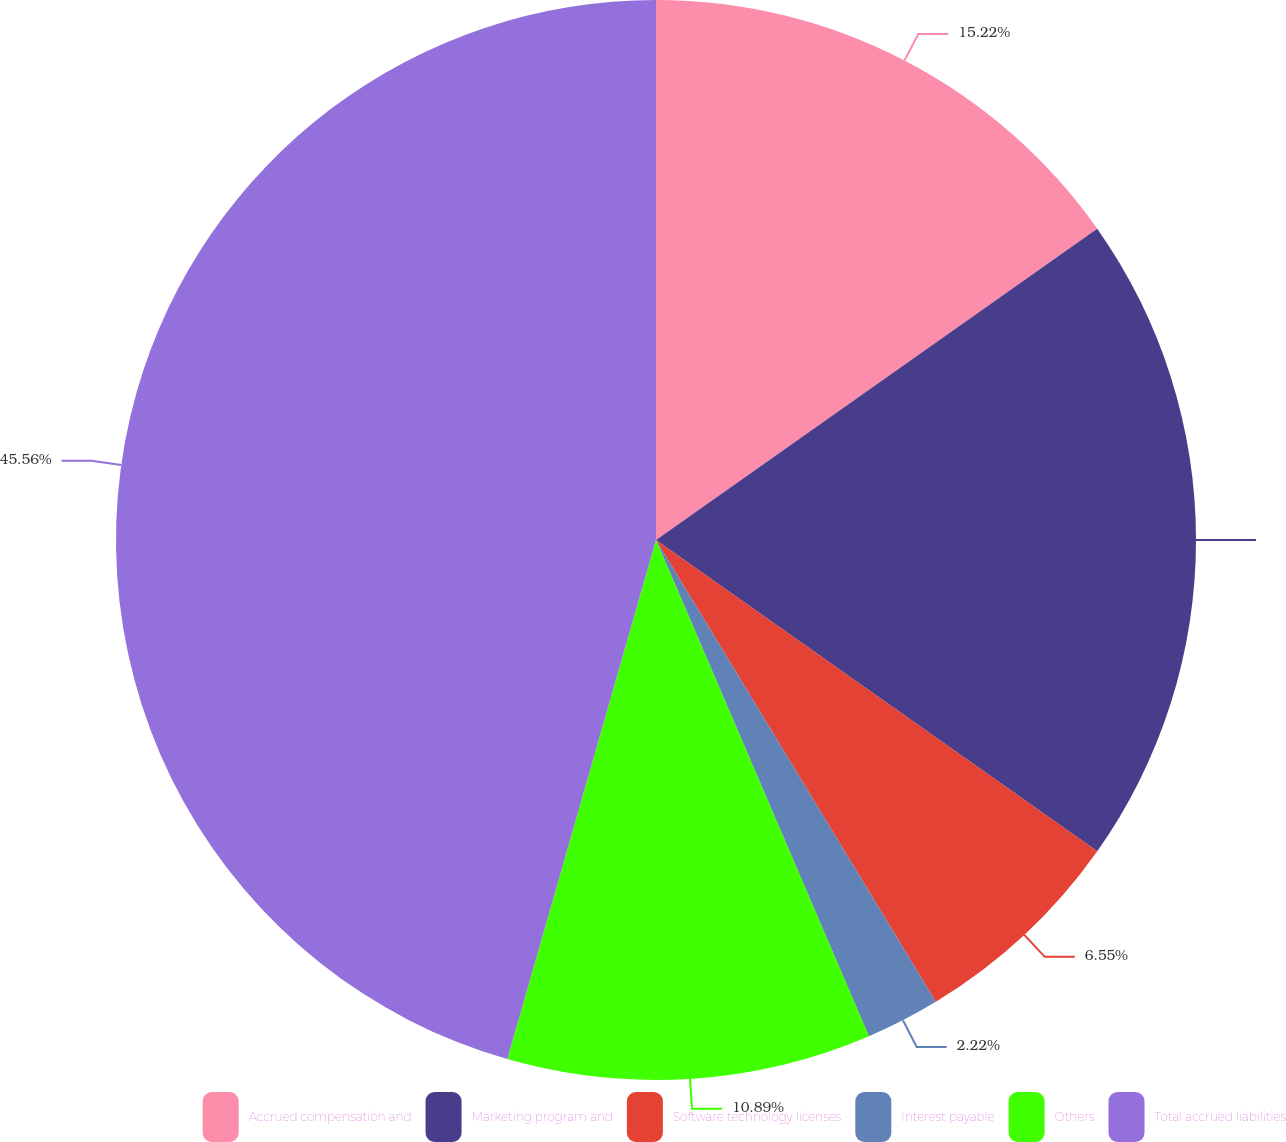Convert chart to OTSL. <chart><loc_0><loc_0><loc_500><loc_500><pie_chart><fcel>Accrued compensation and<fcel>Marketing program and<fcel>Software technology licenses<fcel>Interest payable<fcel>Others<fcel>Total accrued liabilities<nl><fcel>15.22%<fcel>19.56%<fcel>6.55%<fcel>2.22%<fcel>10.89%<fcel>45.56%<nl></chart> 